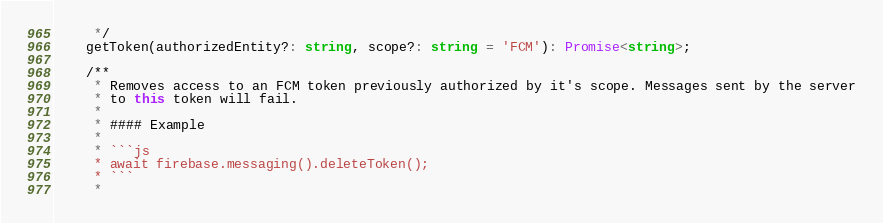Convert code to text. <code><loc_0><loc_0><loc_500><loc_500><_TypeScript_>     */
    getToken(authorizedEntity?: string, scope?: string = 'FCM'): Promise<string>;

    /**
     * Removes access to an FCM token previously authorized by it's scope. Messages sent by the server
     * to this token will fail.
     *
     * #### Example
     *
     * ```js
     * await firebase.messaging().deleteToken();
     * ```
     *</code> 